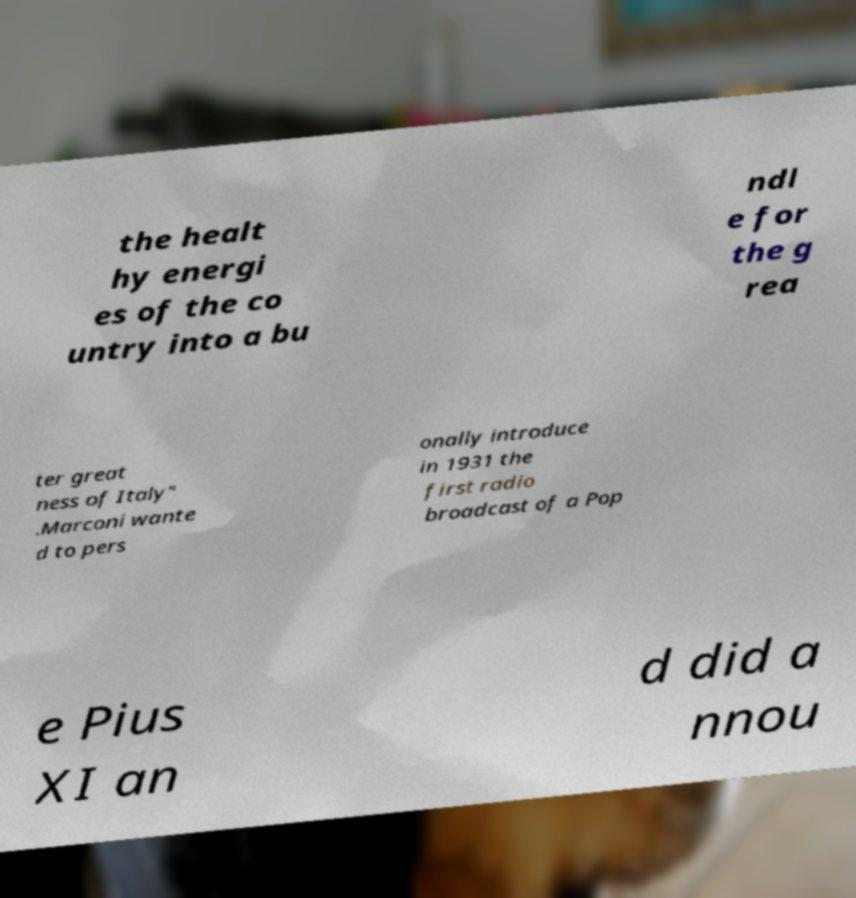Can you read and provide the text displayed in the image?This photo seems to have some interesting text. Can you extract and type it out for me? the healt hy energi es of the co untry into a bu ndl e for the g rea ter great ness of Italy" .Marconi wante d to pers onally introduce in 1931 the first radio broadcast of a Pop e Pius XI an d did a nnou 